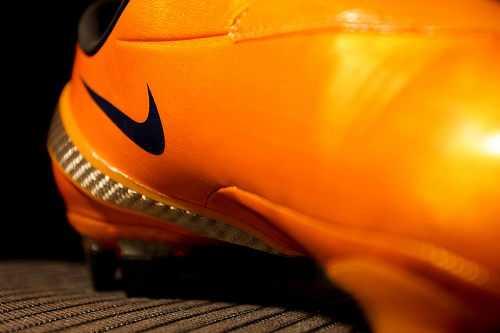<image>
Is the boot under the logo? No. The boot is not positioned under the logo. The vertical relationship between these objects is different. 